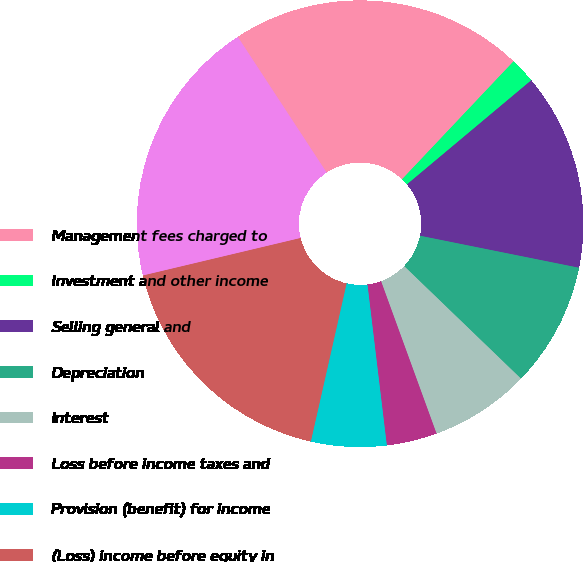Convert chart to OTSL. <chart><loc_0><loc_0><loc_500><loc_500><pie_chart><fcel>Management fees charged to<fcel>Investment and other income<fcel>Selling general and<fcel>Depreciation<fcel>Interest<fcel>Loss before income taxes and<fcel>Provision (benefit) for income<fcel>(Loss) income before equity in<fcel>Equity in net earnings of<fcel>Net income<nl><fcel>21.28%<fcel>1.85%<fcel>14.26%<fcel>9.04%<fcel>7.24%<fcel>3.65%<fcel>5.45%<fcel>0.05%<fcel>17.69%<fcel>19.49%<nl></chart> 